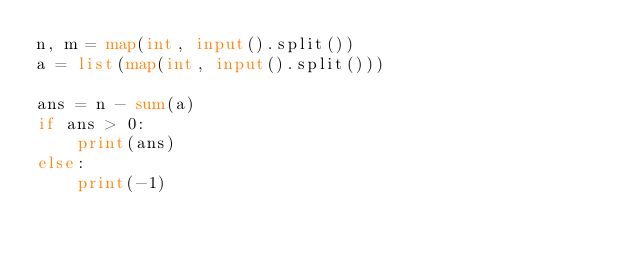Convert code to text. <code><loc_0><loc_0><loc_500><loc_500><_Python_>n, m = map(int, input().split())
a = list(map(int, input().split()))

ans = n - sum(a)
if ans > 0:
    print(ans)
else:
    print(-1)

</code> 